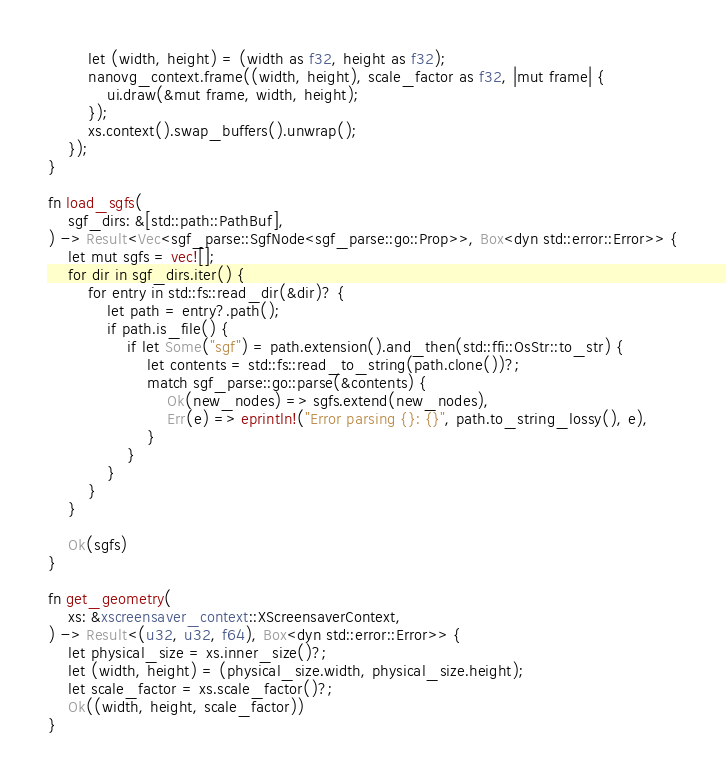Convert code to text. <code><loc_0><loc_0><loc_500><loc_500><_Rust_>        let (width, height) = (width as f32, height as f32);
        nanovg_context.frame((width, height), scale_factor as f32, |mut frame| {
            ui.draw(&mut frame, width, height);
        });
        xs.context().swap_buffers().unwrap();
    });
}

fn load_sgfs(
    sgf_dirs: &[std::path::PathBuf],
) -> Result<Vec<sgf_parse::SgfNode<sgf_parse::go::Prop>>, Box<dyn std::error::Error>> {
    let mut sgfs = vec![];
    for dir in sgf_dirs.iter() {
        for entry in std::fs::read_dir(&dir)? {
            let path = entry?.path();
            if path.is_file() {
                if let Some("sgf") = path.extension().and_then(std::ffi::OsStr::to_str) {
                    let contents = std::fs::read_to_string(path.clone())?;
                    match sgf_parse::go::parse(&contents) {
                        Ok(new_nodes) => sgfs.extend(new_nodes),
                        Err(e) => eprintln!("Error parsing {}: {}", path.to_string_lossy(), e),
                    }
                }
            }
        }
    }

    Ok(sgfs)
}

fn get_geometry(
    xs: &xscreensaver_context::XScreensaverContext,
) -> Result<(u32, u32, f64), Box<dyn std::error::Error>> {
    let physical_size = xs.inner_size()?;
    let (width, height) = (physical_size.width, physical_size.height);
    let scale_factor = xs.scale_factor()?;
    Ok((width, height, scale_factor))
}
</code> 